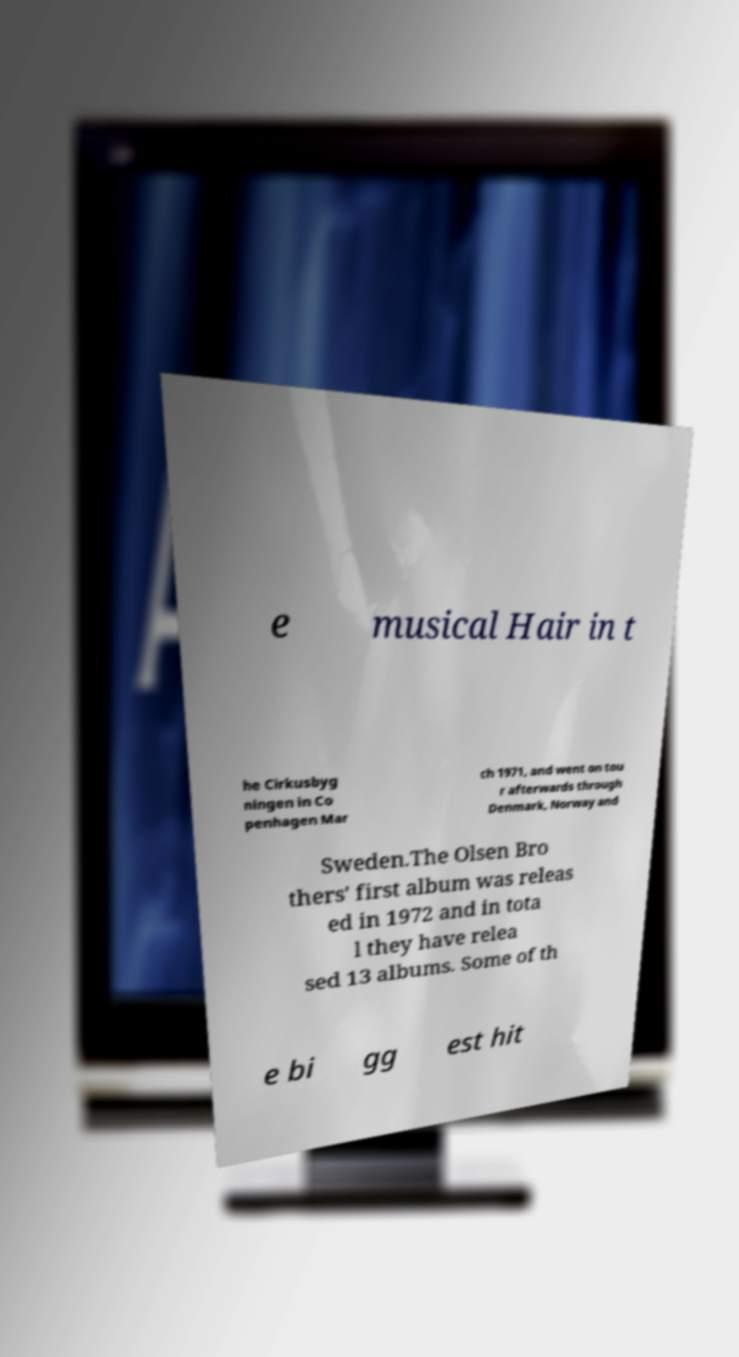Could you extract and type out the text from this image? e musical Hair in t he Cirkusbyg ningen in Co penhagen Mar ch 1971, and went on tou r afterwards through Denmark, Norway and Sweden.The Olsen Bro thers' first album was releas ed in 1972 and in tota l they have relea sed 13 albums. Some of th e bi gg est hit 